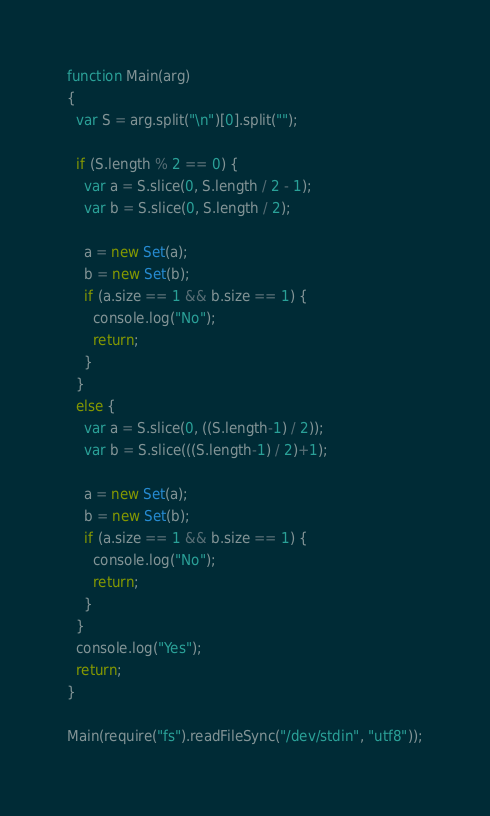Convert code to text. <code><loc_0><loc_0><loc_500><loc_500><_JavaScript_>
function Main(arg) 
{
  var S = arg.split("\n")[0].split("");

  if (S.length % 2 == 0) {
    var a = S.slice(0, S.length / 2 - 1);
    var b = S.slice(0, S.length / 2);

    a = new Set(a);
    b = new Set(b);
    if (a.size == 1 && b.size == 1) {
      console.log("No");
      return;
    }
  }
  else {
    var a = S.slice(0, ((S.length-1) / 2));
    var b = S.slice(((S.length-1) / 2)+1);

    a = new Set(a);
    b = new Set(b);
    if (a.size == 1 && b.size == 1) {
      console.log("No");
      return;
    }
  }
  console.log("Yes");
  return;
}

Main(require("fs").readFileSync("/dev/stdin", "utf8"));</code> 